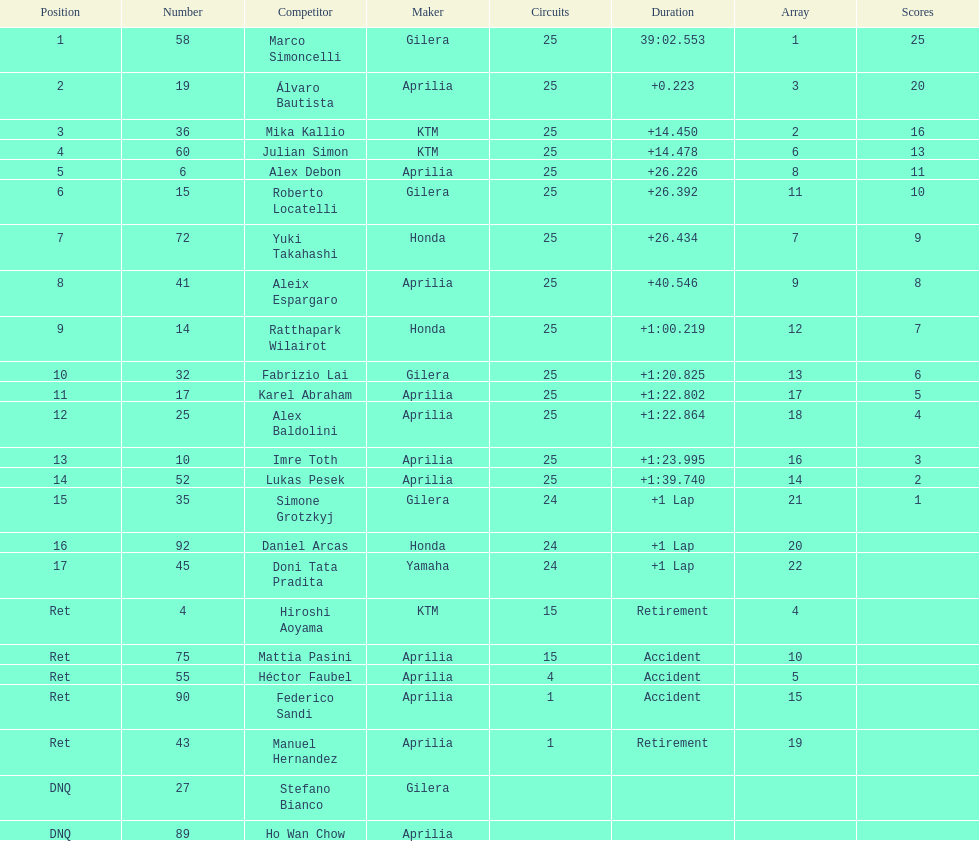How many riders manufacturer is honda? 3. 